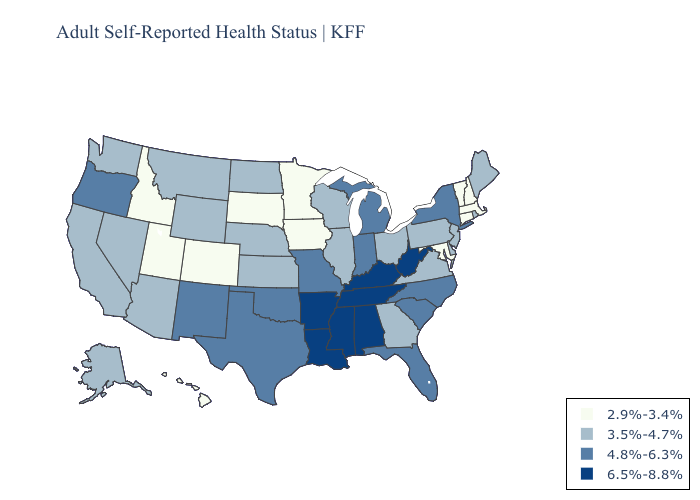Does West Virginia have a lower value than South Dakota?
Be succinct. No. Which states hav the highest value in the South?
Give a very brief answer. Alabama, Arkansas, Kentucky, Louisiana, Mississippi, Tennessee, West Virginia. What is the highest value in states that border Arkansas?
Concise answer only. 6.5%-8.8%. Does Nebraska have the highest value in the USA?
Answer briefly. No. Name the states that have a value in the range 2.9%-3.4%?
Concise answer only. Colorado, Connecticut, Hawaii, Idaho, Iowa, Maryland, Massachusetts, Minnesota, New Hampshire, South Dakota, Utah, Vermont. Among the states that border Alabama , does Georgia have the lowest value?
Be succinct. Yes. What is the value of Oregon?
Keep it brief. 4.8%-6.3%. Name the states that have a value in the range 2.9%-3.4%?
Answer briefly. Colorado, Connecticut, Hawaii, Idaho, Iowa, Maryland, Massachusetts, Minnesota, New Hampshire, South Dakota, Utah, Vermont. Which states have the lowest value in the USA?
Concise answer only. Colorado, Connecticut, Hawaii, Idaho, Iowa, Maryland, Massachusetts, Minnesota, New Hampshire, South Dakota, Utah, Vermont. Is the legend a continuous bar?
Keep it brief. No. What is the value of Tennessee?
Be succinct. 6.5%-8.8%. Which states hav the highest value in the South?
Write a very short answer. Alabama, Arkansas, Kentucky, Louisiana, Mississippi, Tennessee, West Virginia. How many symbols are there in the legend?
Be succinct. 4. What is the value of Maryland?
Quick response, please. 2.9%-3.4%. What is the value of Oregon?
Be succinct. 4.8%-6.3%. 